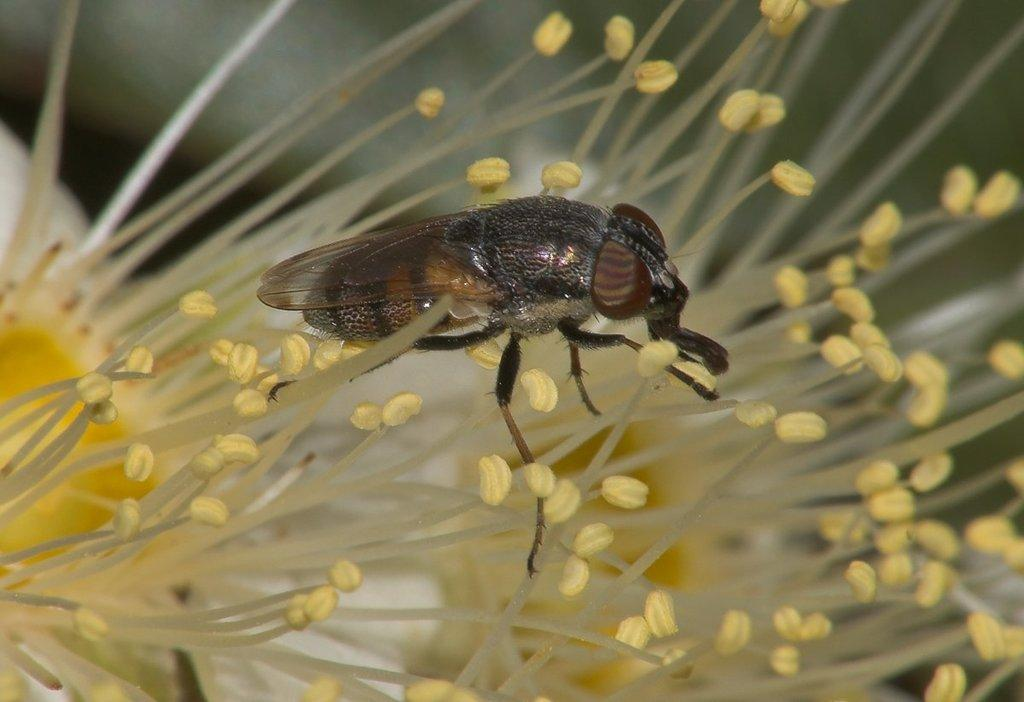What is present in the image? There is a fly in the image. Where is the fly located? The fly is present on pollen grains. What are the pollen grains from? The pollen grains are from a flower. What type of substance is the fly using to create a chain in the image? There is no chain present in the image, and the fly is not using any substance to create one. 